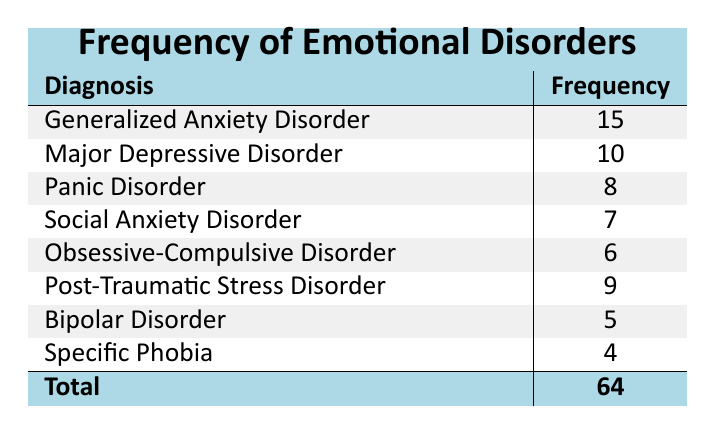What is the most frequently diagnosed emotional disorder in this support group? The table shows that Generalized Anxiety Disorder has the highest frequency of 15 diagnoses, compared to other disorders.
Answer: Generalized Anxiety Disorder How many participants were diagnosed with Major Depressive Disorder? According to the table, Major Depressive Disorder is listed with a frequency of 10.
Answer: 10 What is the total frequency of emotional disorders diagnosed in this support group? By summing up all the frequencies (15 + 10 + 8 + 7 + 6 + 9 + 5 + 4), we get a total of 64.
Answer: 64 Is the frequency of Social Anxiety Disorder greater than that of Bipolar Disorder? The frequency of Social Anxiety Disorder is 7 and Bipolar Disorder is 5. Since 7 is greater than 5, the statement is true.
Answer: Yes What is the average frequency of emotional disorders diagnosed in this support group? To find the average, sum the frequencies (64) and divide by the number of distinct disorders (8). Thus, 64 / 8 = 8.
Answer: 8 How many participants were diagnosed with either Panic Disorder or Post-Traumatic Stress Disorder? Adding the frequencies for Panic Disorder (8) and Post-Traumatic Stress Disorder (9), we calculate 8 + 9 = 17.
Answer: 17 Which emotional disorder is diagnosed the least among the participants? From the table, Specific Phobia has the lowest frequency at 4, making it the least diagnosed disorder.
Answer: Specific Phobia Is it true that the total number of participants diagnosed with Obsessive-Compulsive Disorder equals 6? The table lists the frequency of Obsessive-Compulsive Disorder as 6, so the statement is indeed true.
Answer: Yes What is the difference in frequency between the most commonly and least commonly diagnosed emotional disorders? The most frequently diagnosed disorder is Generalized Anxiety Disorder (15) and the least is Specific Phobia (4). The difference is 15 - 4 = 11.
Answer: 11 